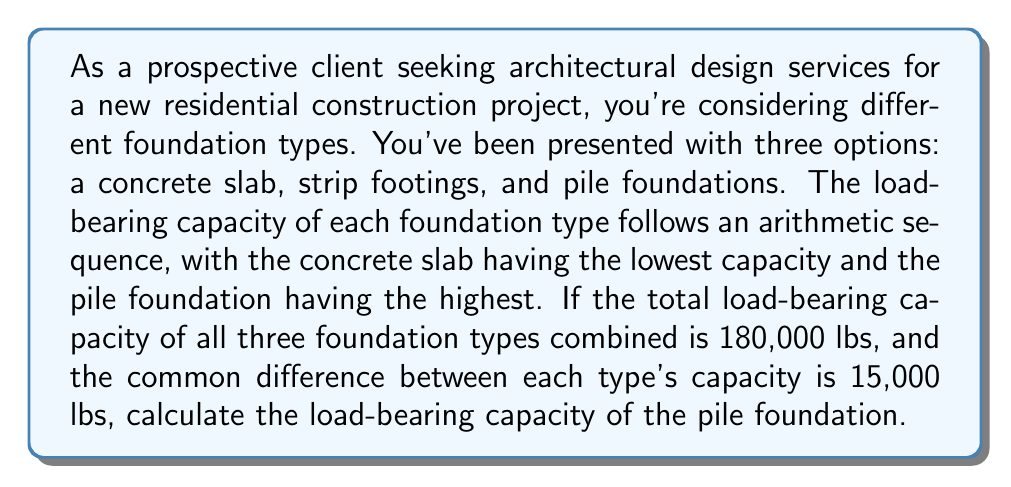Give your solution to this math problem. Let's approach this step-by-step:

1) Let's denote the load-bearing capacities as follows:
   $a_1$ = capacity of concrete slab
   $a_2$ = capacity of strip footings
   $a_3$ = capacity of pile foundation

2) We're told this is an arithmetic sequence with a common difference of 15,000 lbs. So:
   $a_2 = a_1 + 15,000$
   $a_3 = a_2 + 15,000 = a_1 + 30,000$

3) We're also told that the sum of all three capacities is 180,000 lbs. We can express this as:
   $a_1 + a_2 + a_3 = 180,000$

4) Substituting the expressions from step 2 into this equation:
   $a_1 + (a_1 + 15,000) + (a_1 + 30,000) = 180,000$

5) Simplify:
   $3a_1 + 45,000 = 180,000$

6) Solve for $a_1$:
   $3a_1 = 135,000$
   $a_1 = 45,000$

7) Now that we know $a_1$, we can find $a_3$ (the pile foundation capacity):
   $a_3 = a_1 + 30,000 = 45,000 + 30,000 = 75,000$

Therefore, the load-bearing capacity of the pile foundation is 75,000 lbs.
Answer: The load-bearing capacity of the pile foundation is 75,000 lbs. 